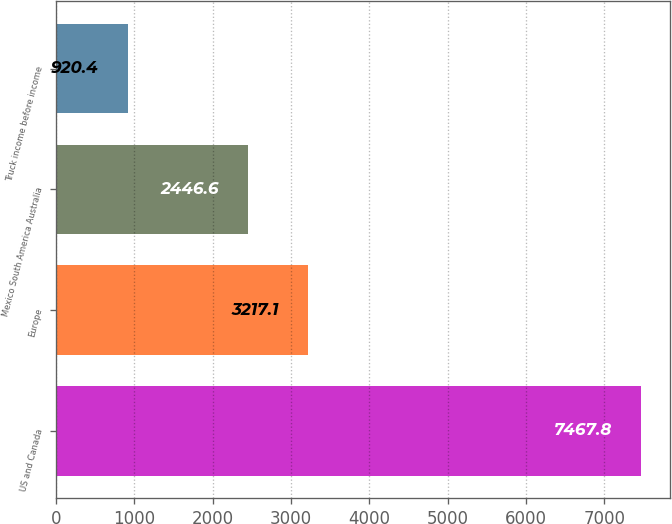Convert chart to OTSL. <chart><loc_0><loc_0><loc_500><loc_500><bar_chart><fcel>US and Canada<fcel>Europe<fcel>Mexico South America Australia<fcel>Truck income before income<nl><fcel>7467.8<fcel>3217.1<fcel>2446.6<fcel>920.4<nl></chart> 